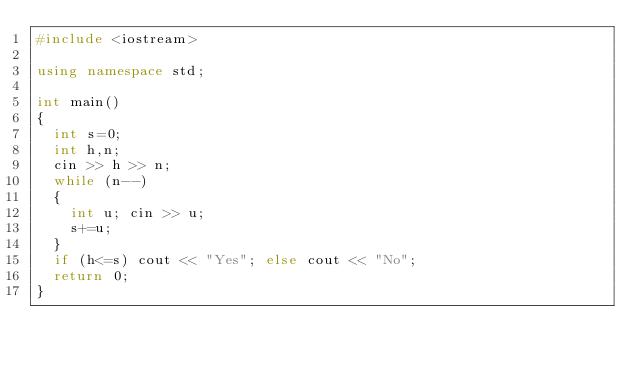<code> <loc_0><loc_0><loc_500><loc_500><_C++_>#include <iostream>

using namespace std;

int main()
{
  int s=0;
  int h,n;
  cin >> h >> n;
  while (n--)
  {
    int u; cin >> u;
    s+=u;
  }
  if (h<=s) cout << "Yes"; else cout << "No";
  return 0;
}</code> 